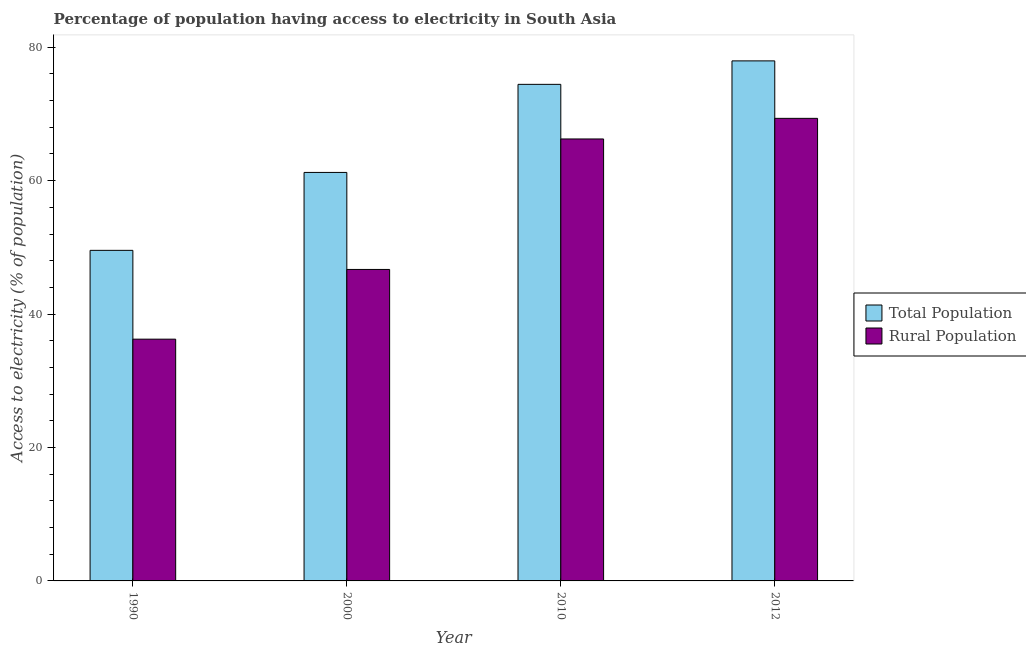How many groups of bars are there?
Make the answer very short. 4. Are the number of bars on each tick of the X-axis equal?
Keep it short and to the point. Yes. In how many cases, is the number of bars for a given year not equal to the number of legend labels?
Provide a succinct answer. 0. What is the percentage of rural population having access to electricity in 2010?
Provide a short and direct response. 66.25. Across all years, what is the maximum percentage of rural population having access to electricity?
Offer a very short reply. 69.34. Across all years, what is the minimum percentage of rural population having access to electricity?
Give a very brief answer. 36.24. In which year was the percentage of population having access to electricity maximum?
Offer a very short reply. 2012. What is the total percentage of rural population having access to electricity in the graph?
Make the answer very short. 218.53. What is the difference between the percentage of population having access to electricity in 1990 and that in 2000?
Keep it short and to the point. -11.68. What is the difference between the percentage of rural population having access to electricity in 1990 and the percentage of population having access to electricity in 2000?
Provide a short and direct response. -10.45. What is the average percentage of population having access to electricity per year?
Provide a short and direct response. 65.8. In the year 2012, what is the difference between the percentage of rural population having access to electricity and percentage of population having access to electricity?
Your response must be concise. 0. In how many years, is the percentage of rural population having access to electricity greater than 28 %?
Your answer should be compact. 4. What is the ratio of the percentage of rural population having access to electricity in 1990 to that in 2010?
Give a very brief answer. 0.55. Is the percentage of population having access to electricity in 1990 less than that in 2000?
Give a very brief answer. Yes. What is the difference between the highest and the second highest percentage of rural population having access to electricity?
Provide a succinct answer. 3.09. What is the difference between the highest and the lowest percentage of rural population having access to electricity?
Your answer should be very brief. 33.1. In how many years, is the percentage of rural population having access to electricity greater than the average percentage of rural population having access to electricity taken over all years?
Offer a very short reply. 2. Is the sum of the percentage of rural population having access to electricity in 2000 and 2010 greater than the maximum percentage of population having access to electricity across all years?
Give a very brief answer. Yes. What does the 1st bar from the left in 2010 represents?
Your answer should be compact. Total Population. What does the 2nd bar from the right in 1990 represents?
Provide a succinct answer. Total Population. Are all the bars in the graph horizontal?
Offer a terse response. No. Are the values on the major ticks of Y-axis written in scientific E-notation?
Make the answer very short. No. How many legend labels are there?
Offer a terse response. 2. How are the legend labels stacked?
Provide a succinct answer. Vertical. What is the title of the graph?
Ensure brevity in your answer.  Percentage of population having access to electricity in South Asia. What is the label or title of the Y-axis?
Make the answer very short. Access to electricity (% of population). What is the Access to electricity (% of population) in Total Population in 1990?
Offer a terse response. 49.55. What is the Access to electricity (% of population) of Rural Population in 1990?
Your answer should be compact. 36.24. What is the Access to electricity (% of population) of Total Population in 2000?
Offer a terse response. 61.23. What is the Access to electricity (% of population) of Rural Population in 2000?
Give a very brief answer. 46.69. What is the Access to electricity (% of population) of Total Population in 2010?
Your answer should be very brief. 74.44. What is the Access to electricity (% of population) in Rural Population in 2010?
Your answer should be very brief. 66.25. What is the Access to electricity (% of population) in Total Population in 2012?
Offer a terse response. 77.96. What is the Access to electricity (% of population) in Rural Population in 2012?
Your response must be concise. 69.34. Across all years, what is the maximum Access to electricity (% of population) in Total Population?
Give a very brief answer. 77.96. Across all years, what is the maximum Access to electricity (% of population) in Rural Population?
Ensure brevity in your answer.  69.34. Across all years, what is the minimum Access to electricity (% of population) of Total Population?
Offer a terse response. 49.55. Across all years, what is the minimum Access to electricity (% of population) in Rural Population?
Make the answer very short. 36.24. What is the total Access to electricity (% of population) of Total Population in the graph?
Offer a very short reply. 263.19. What is the total Access to electricity (% of population) of Rural Population in the graph?
Provide a short and direct response. 218.53. What is the difference between the Access to electricity (% of population) in Total Population in 1990 and that in 2000?
Your answer should be compact. -11.68. What is the difference between the Access to electricity (% of population) in Rural Population in 1990 and that in 2000?
Keep it short and to the point. -10.45. What is the difference between the Access to electricity (% of population) in Total Population in 1990 and that in 2010?
Keep it short and to the point. -24.88. What is the difference between the Access to electricity (% of population) of Rural Population in 1990 and that in 2010?
Give a very brief answer. -30.01. What is the difference between the Access to electricity (% of population) of Total Population in 1990 and that in 2012?
Provide a succinct answer. -28.4. What is the difference between the Access to electricity (% of population) in Rural Population in 1990 and that in 2012?
Provide a short and direct response. -33.1. What is the difference between the Access to electricity (% of population) of Total Population in 2000 and that in 2010?
Offer a very short reply. -13.2. What is the difference between the Access to electricity (% of population) of Rural Population in 2000 and that in 2010?
Keep it short and to the point. -19.56. What is the difference between the Access to electricity (% of population) in Total Population in 2000 and that in 2012?
Offer a very short reply. -16.72. What is the difference between the Access to electricity (% of population) in Rural Population in 2000 and that in 2012?
Provide a succinct answer. -22.65. What is the difference between the Access to electricity (% of population) of Total Population in 2010 and that in 2012?
Your answer should be compact. -3.52. What is the difference between the Access to electricity (% of population) of Rural Population in 2010 and that in 2012?
Make the answer very short. -3.09. What is the difference between the Access to electricity (% of population) in Total Population in 1990 and the Access to electricity (% of population) in Rural Population in 2000?
Provide a short and direct response. 2.86. What is the difference between the Access to electricity (% of population) of Total Population in 1990 and the Access to electricity (% of population) of Rural Population in 2010?
Your answer should be compact. -16.7. What is the difference between the Access to electricity (% of population) of Total Population in 1990 and the Access to electricity (% of population) of Rural Population in 2012?
Your answer should be very brief. -19.79. What is the difference between the Access to electricity (% of population) in Total Population in 2000 and the Access to electricity (% of population) in Rural Population in 2010?
Provide a short and direct response. -5.02. What is the difference between the Access to electricity (% of population) in Total Population in 2000 and the Access to electricity (% of population) in Rural Population in 2012?
Offer a very short reply. -8.11. What is the difference between the Access to electricity (% of population) of Total Population in 2010 and the Access to electricity (% of population) of Rural Population in 2012?
Keep it short and to the point. 5.1. What is the average Access to electricity (% of population) in Total Population per year?
Keep it short and to the point. 65.8. What is the average Access to electricity (% of population) in Rural Population per year?
Provide a succinct answer. 54.63. In the year 1990, what is the difference between the Access to electricity (% of population) of Total Population and Access to electricity (% of population) of Rural Population?
Keep it short and to the point. 13.31. In the year 2000, what is the difference between the Access to electricity (% of population) of Total Population and Access to electricity (% of population) of Rural Population?
Offer a terse response. 14.54. In the year 2010, what is the difference between the Access to electricity (% of population) in Total Population and Access to electricity (% of population) in Rural Population?
Your answer should be compact. 8.19. In the year 2012, what is the difference between the Access to electricity (% of population) of Total Population and Access to electricity (% of population) of Rural Population?
Provide a succinct answer. 8.62. What is the ratio of the Access to electricity (% of population) in Total Population in 1990 to that in 2000?
Give a very brief answer. 0.81. What is the ratio of the Access to electricity (% of population) in Rural Population in 1990 to that in 2000?
Ensure brevity in your answer.  0.78. What is the ratio of the Access to electricity (% of population) of Total Population in 1990 to that in 2010?
Keep it short and to the point. 0.67. What is the ratio of the Access to electricity (% of population) of Rural Population in 1990 to that in 2010?
Offer a terse response. 0.55. What is the ratio of the Access to electricity (% of population) in Total Population in 1990 to that in 2012?
Keep it short and to the point. 0.64. What is the ratio of the Access to electricity (% of population) of Rural Population in 1990 to that in 2012?
Your response must be concise. 0.52. What is the ratio of the Access to electricity (% of population) of Total Population in 2000 to that in 2010?
Your response must be concise. 0.82. What is the ratio of the Access to electricity (% of population) in Rural Population in 2000 to that in 2010?
Ensure brevity in your answer.  0.7. What is the ratio of the Access to electricity (% of population) of Total Population in 2000 to that in 2012?
Make the answer very short. 0.79. What is the ratio of the Access to electricity (% of population) of Rural Population in 2000 to that in 2012?
Keep it short and to the point. 0.67. What is the ratio of the Access to electricity (% of population) in Total Population in 2010 to that in 2012?
Make the answer very short. 0.95. What is the ratio of the Access to electricity (% of population) of Rural Population in 2010 to that in 2012?
Your response must be concise. 0.96. What is the difference between the highest and the second highest Access to electricity (% of population) of Total Population?
Offer a very short reply. 3.52. What is the difference between the highest and the second highest Access to electricity (% of population) of Rural Population?
Your answer should be very brief. 3.09. What is the difference between the highest and the lowest Access to electricity (% of population) in Total Population?
Keep it short and to the point. 28.4. What is the difference between the highest and the lowest Access to electricity (% of population) in Rural Population?
Provide a succinct answer. 33.1. 